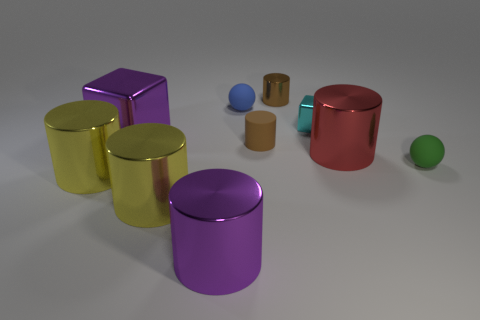Subtract 2 cylinders. How many cylinders are left? 4 Subtract all red cylinders. How many cylinders are left? 5 Subtract all brown metallic cylinders. How many cylinders are left? 5 Subtract all red cylinders. Subtract all purple spheres. How many cylinders are left? 5 Subtract all spheres. How many objects are left? 8 Subtract 0 cyan spheres. How many objects are left? 10 Subtract all spheres. Subtract all green rubber spheres. How many objects are left? 7 Add 3 tiny brown shiny things. How many tiny brown shiny things are left? 4 Add 7 blue things. How many blue things exist? 8 